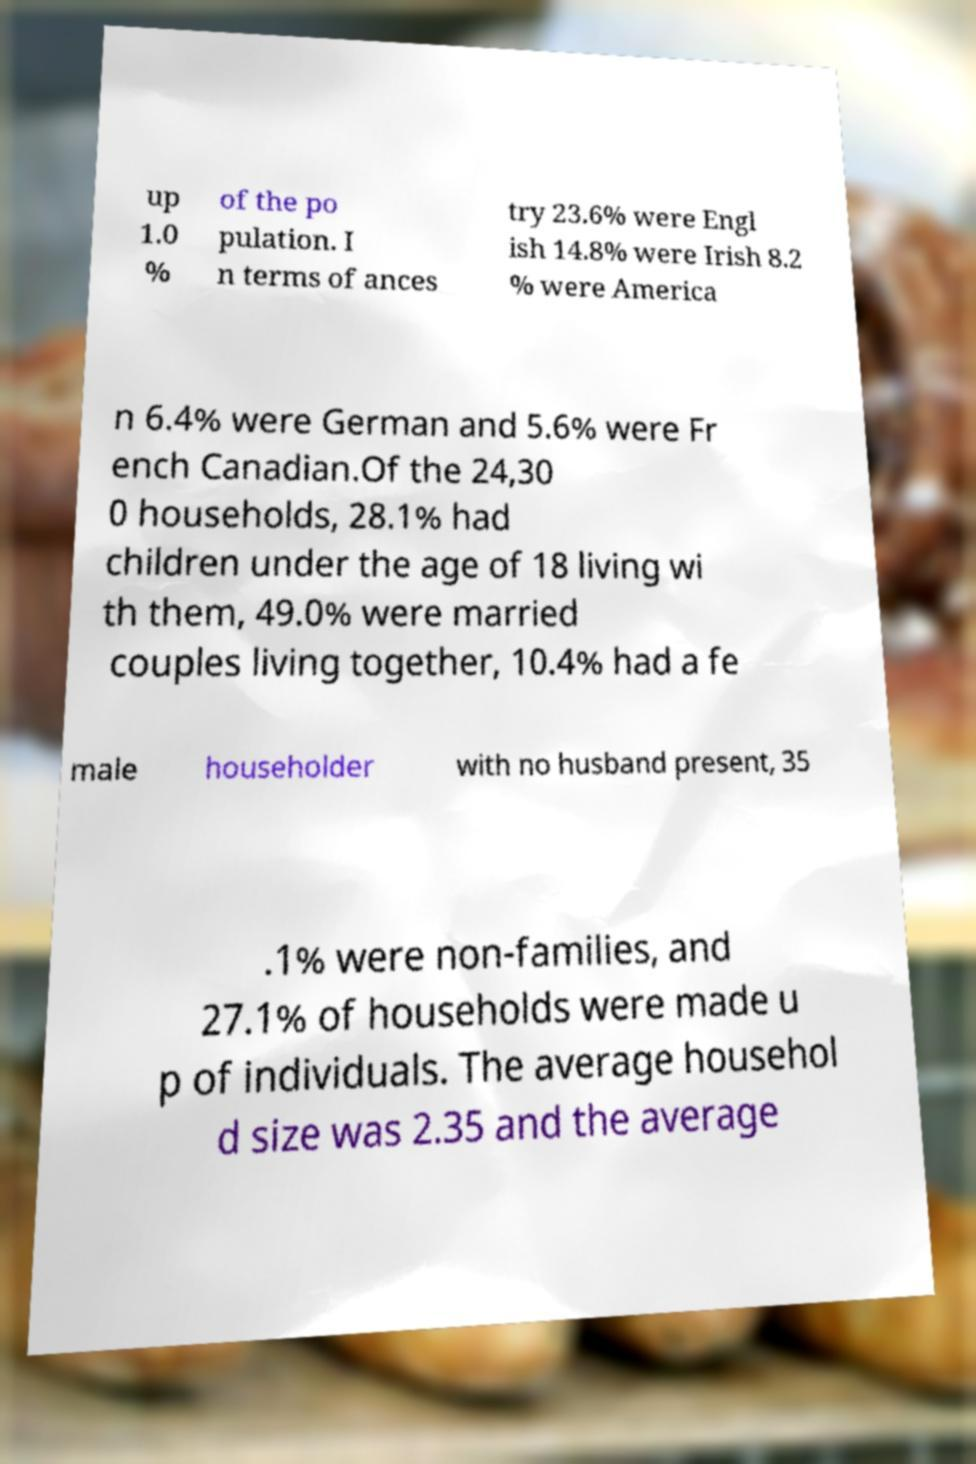There's text embedded in this image that I need extracted. Can you transcribe it verbatim? up 1.0 % of the po pulation. I n terms of ances try 23.6% were Engl ish 14.8% were Irish 8.2 % were America n 6.4% were German and 5.6% were Fr ench Canadian.Of the 24,30 0 households, 28.1% had children under the age of 18 living wi th them, 49.0% were married couples living together, 10.4% had a fe male householder with no husband present, 35 .1% were non-families, and 27.1% of households were made u p of individuals. The average househol d size was 2.35 and the average 